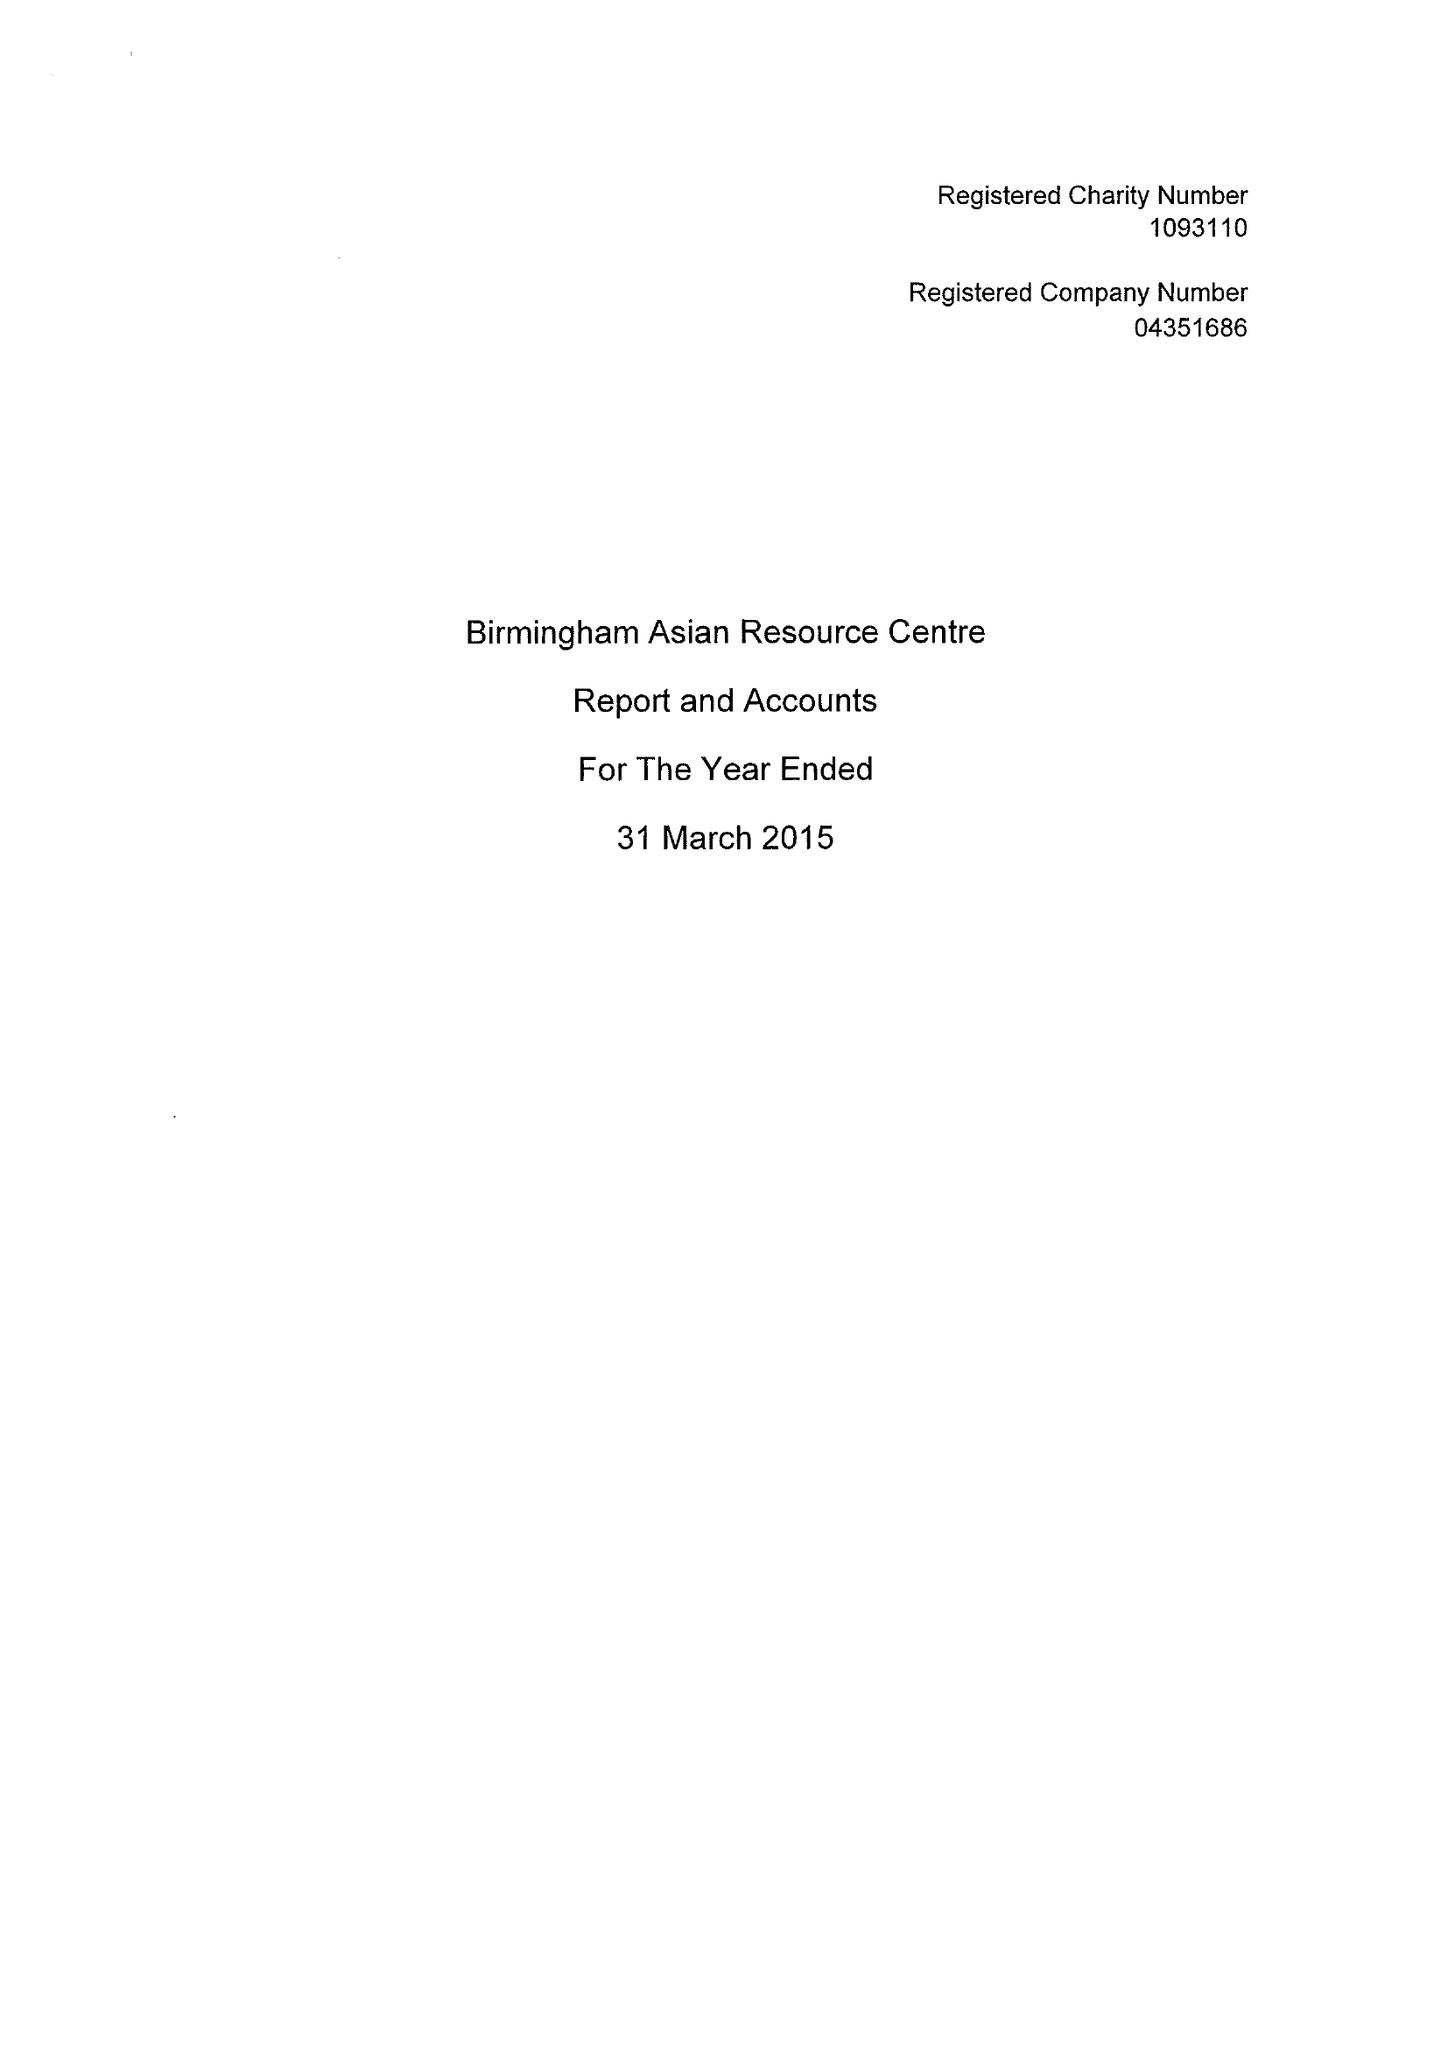What is the value for the spending_annually_in_british_pounds?
Answer the question using a single word or phrase. 232040.00 